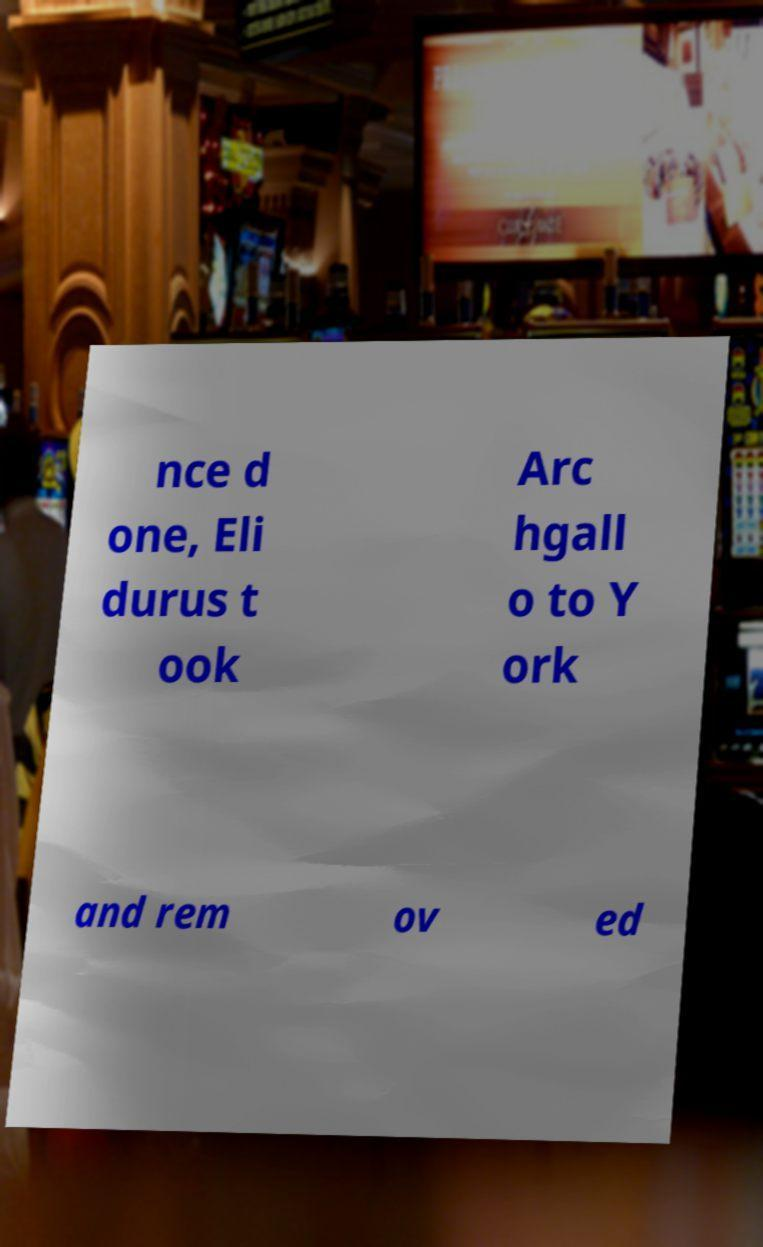Could you extract and type out the text from this image? nce d one, Eli durus t ook Arc hgall o to Y ork and rem ov ed 